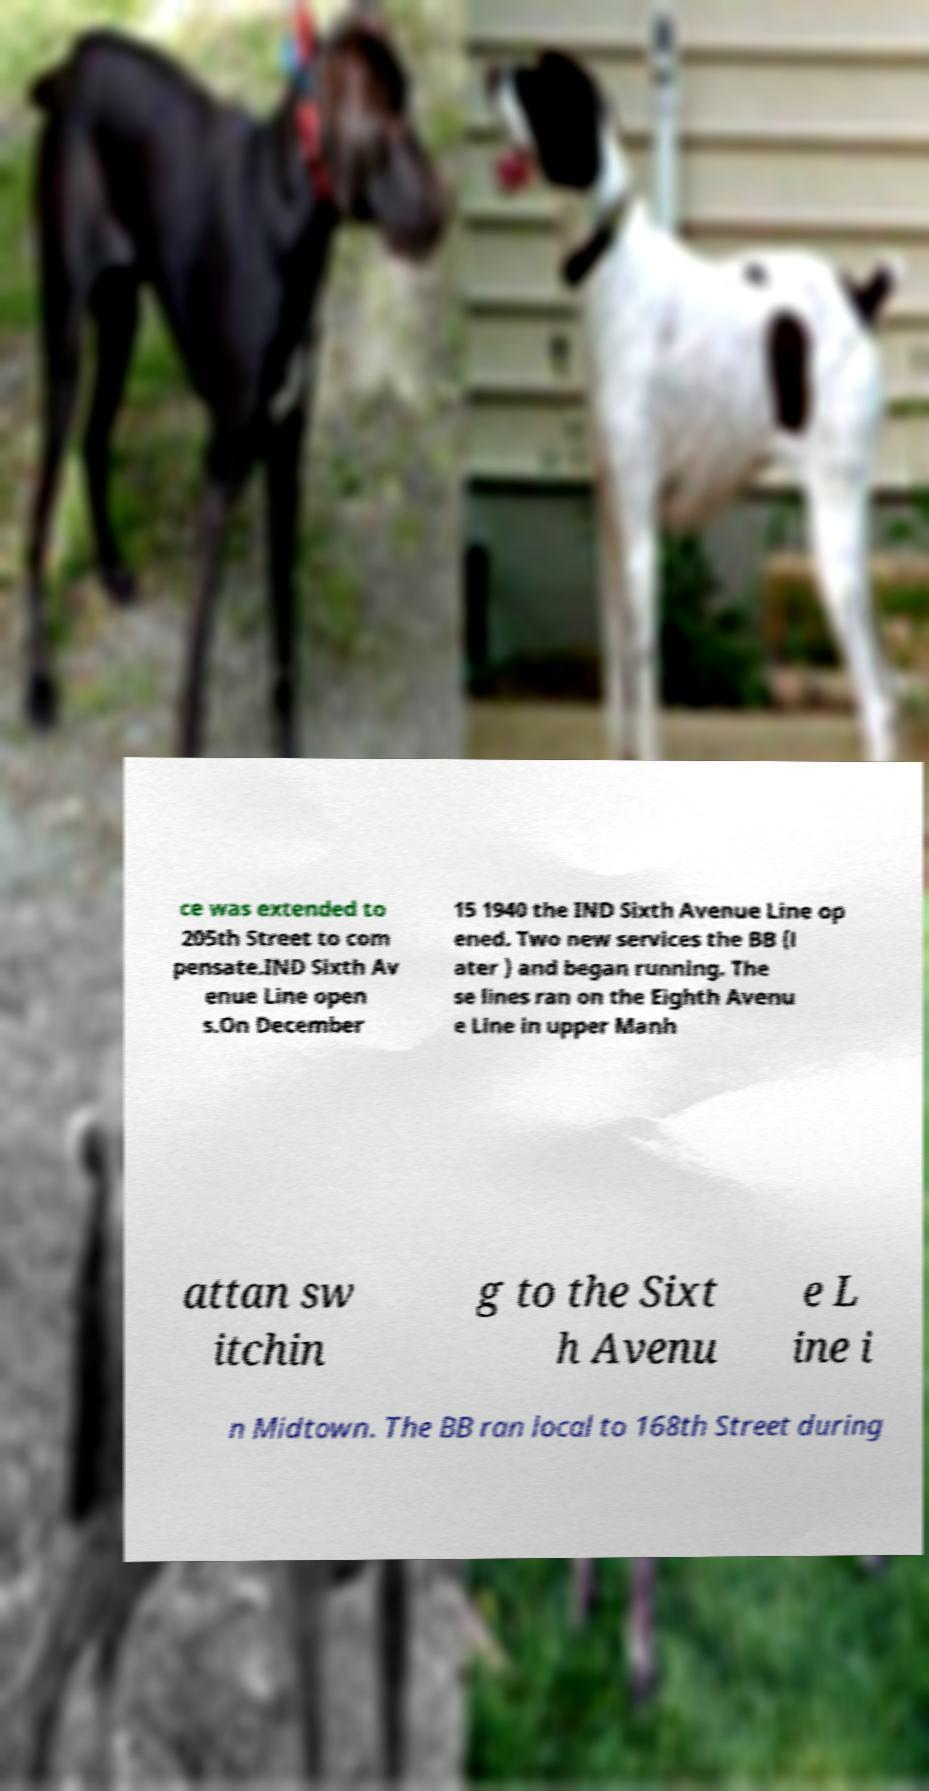Please read and relay the text visible in this image. What does it say? ce was extended to 205th Street to com pensate.IND Sixth Av enue Line open s.On December 15 1940 the IND Sixth Avenue Line op ened. Two new services the BB (l ater ) and began running. The se lines ran on the Eighth Avenu e Line in upper Manh attan sw itchin g to the Sixt h Avenu e L ine i n Midtown. The BB ran local to 168th Street during 